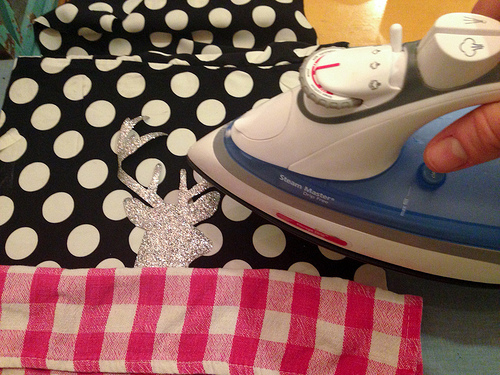<image>
Is there a iron on the fabric? Yes. Looking at the image, I can see the iron is positioned on top of the fabric, with the fabric providing support. 